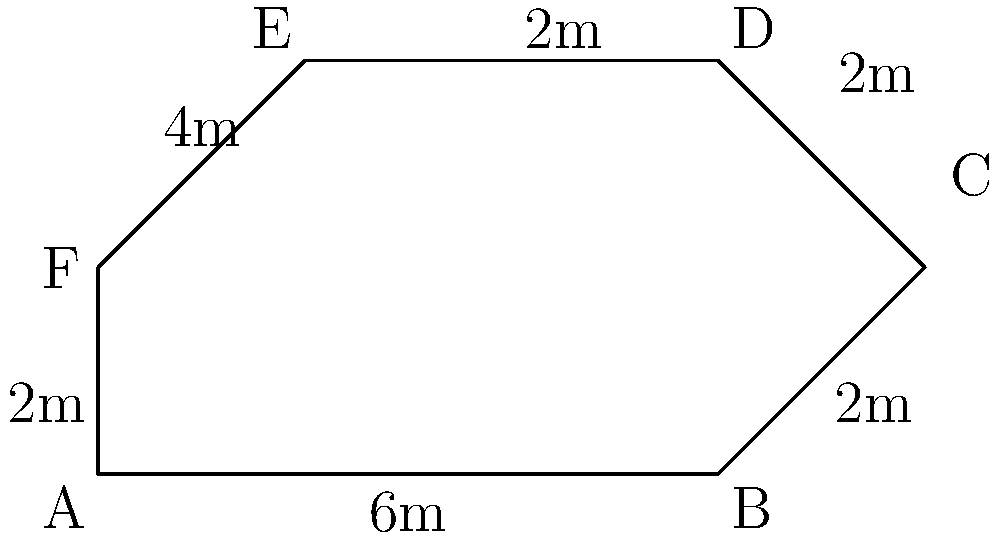As the CEO of an oil and gas company, you're overseeing the construction of a new offshore platform with an irregular hexagonal shape. The platform's dimensions are shown in the diagram above. Calculate the total area of the platform in square meters to determine the amount of non-slip flooring material needed. Round your answer to the nearest whole number. To calculate the area of this irregular hexagon, we can divide it into simpler shapes:

1. First, divide the hexagon into a rectangle and two triangles.

2. Calculate the area of the rectangle:
   Length = 6m, Width = 4m
   Area of rectangle = $6m \times 4m = 24m^2$

3. Calculate the area of the right triangle on the right:
   Base = 2m, Height = 2m
   Area of right triangle = $\frac{1}{2} \times 2m \times 2m = 2m^2$

4. Calculate the area of the right triangle on the left:
   Base = 2m, Height = 2m
   Area of left triangle = $\frac{1}{2} \times 2m \times 2m = 2m^2$

5. Sum up all areas:
   Total Area = Rectangle + Right Triangle + Left Triangle
               = $24m^2 + 2m^2 + 2m^2 = 28m^2$

6. Round to the nearest whole number:
   $28m^2$ (no rounding needed)

Therefore, the total area of the platform is 28 square meters.
Answer: 28 $m^2$ 